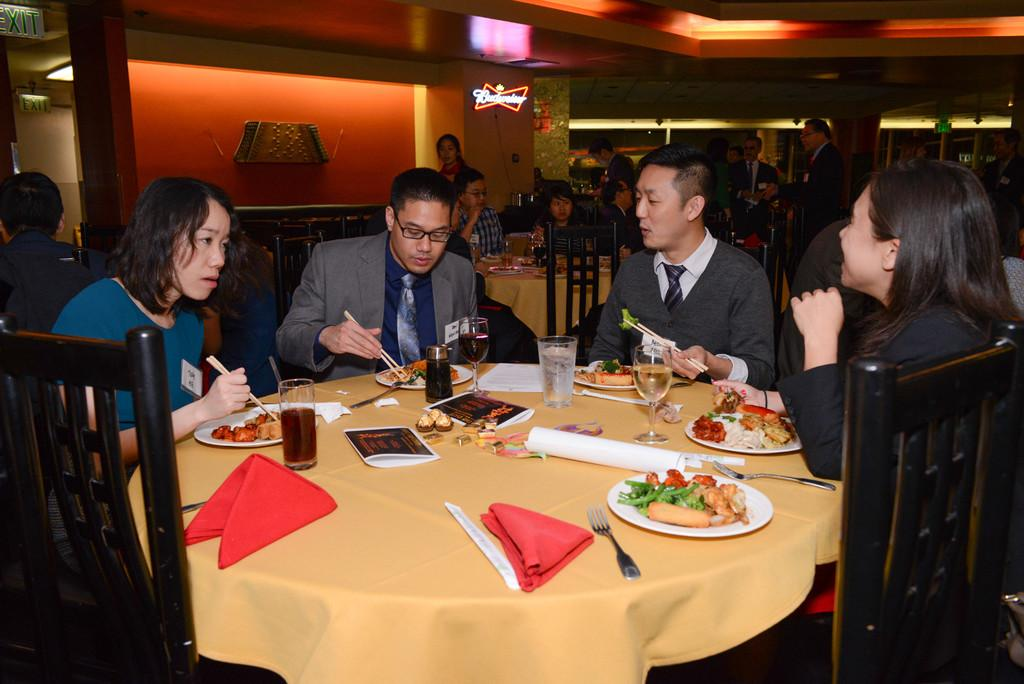What are the people in the image doing? The people in the image are sitting on chairs. What is present on the table in the image? There is a plate, a fork, a juice glass, and a kerchief on the table. What is on the plate? The plate contains food items. What type of ray is swimming under the table in the image? There is no ray present in the image; it is a scene involving people sitting on chairs and a table with various items. 